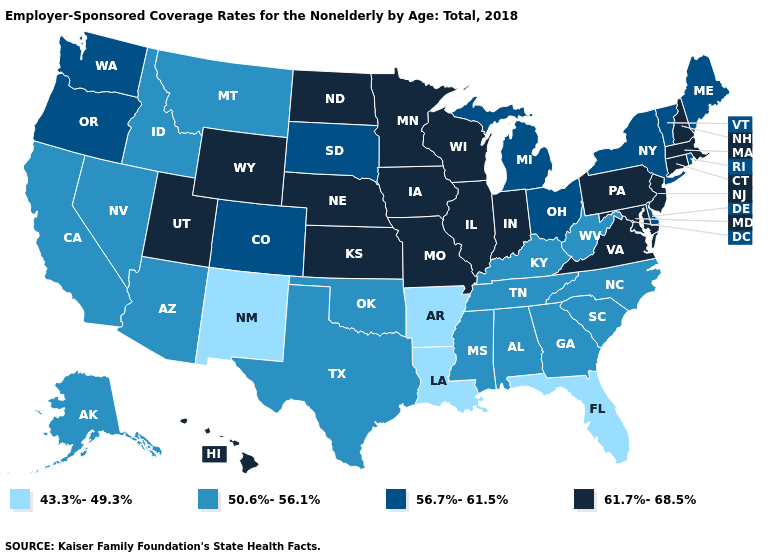What is the value of Pennsylvania?
Short answer required. 61.7%-68.5%. Does Colorado have the same value as Nebraska?
Keep it brief. No. Does Oregon have the same value as Ohio?
Be succinct. Yes. What is the highest value in the West ?
Be succinct. 61.7%-68.5%. Does Delaware have a lower value than Missouri?
Answer briefly. Yes. What is the value of Missouri?
Quick response, please. 61.7%-68.5%. Name the states that have a value in the range 50.6%-56.1%?
Answer briefly. Alabama, Alaska, Arizona, California, Georgia, Idaho, Kentucky, Mississippi, Montana, Nevada, North Carolina, Oklahoma, South Carolina, Tennessee, Texas, West Virginia. Name the states that have a value in the range 61.7%-68.5%?
Keep it brief. Connecticut, Hawaii, Illinois, Indiana, Iowa, Kansas, Maryland, Massachusetts, Minnesota, Missouri, Nebraska, New Hampshire, New Jersey, North Dakota, Pennsylvania, Utah, Virginia, Wisconsin, Wyoming. Name the states that have a value in the range 56.7%-61.5%?
Keep it brief. Colorado, Delaware, Maine, Michigan, New York, Ohio, Oregon, Rhode Island, South Dakota, Vermont, Washington. What is the value of Mississippi?
Quick response, please. 50.6%-56.1%. Name the states that have a value in the range 50.6%-56.1%?
Be succinct. Alabama, Alaska, Arizona, California, Georgia, Idaho, Kentucky, Mississippi, Montana, Nevada, North Carolina, Oklahoma, South Carolina, Tennessee, Texas, West Virginia. Does New Mexico have the lowest value in the West?
Short answer required. Yes. What is the highest value in the USA?
Write a very short answer. 61.7%-68.5%. Which states have the lowest value in the USA?
Answer briefly. Arkansas, Florida, Louisiana, New Mexico. Does Oklahoma have a higher value than South Carolina?
Keep it brief. No. 